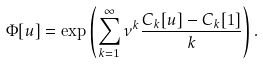<formula> <loc_0><loc_0><loc_500><loc_500>\Phi [ u ] = \exp \left ( \sum _ { k = 1 } ^ { \infty } \nu ^ { k } \frac { C _ { k } [ u ] - C _ { k } [ 1 ] } { k } \right ) .</formula> 